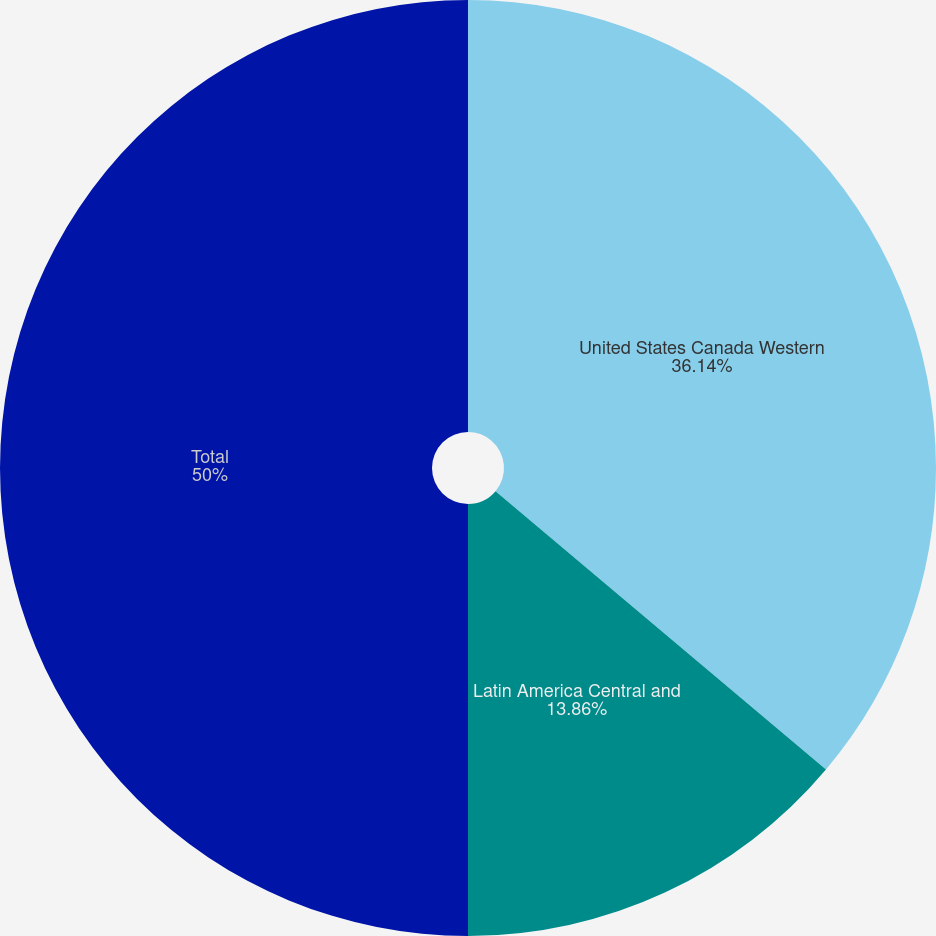<chart> <loc_0><loc_0><loc_500><loc_500><pie_chart><fcel>United States Canada Western<fcel>Latin America Central and<fcel>Total<nl><fcel>36.14%<fcel>13.86%<fcel>50.0%<nl></chart> 